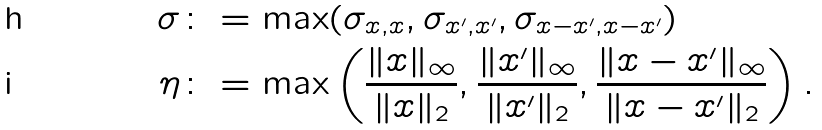Convert formula to latex. <formula><loc_0><loc_0><loc_500><loc_500>\sigma & \colon = \max ( \sigma _ { x , x } , \sigma _ { x ^ { \prime } , x ^ { \prime } } , \sigma _ { x - x ^ { \prime } , x - x ^ { \prime } } ) \\ \eta & \colon = \max \left ( \frac { \| x \| _ { \infty } } { \| x \| _ { 2 } } , \frac { \| x ^ { \prime } \| _ { \infty } } { \| x ^ { \prime } \| _ { 2 } } , \frac { \| x - x ^ { \prime } \| _ { \infty } } { \| x - x ^ { \prime } \| _ { 2 } } \right ) .</formula> 